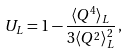<formula> <loc_0><loc_0><loc_500><loc_500>U _ { L } = 1 - \frac { \langle Q ^ { 4 } \rangle _ { L } } { 3 \langle Q ^ { 2 } \rangle ^ { 2 } _ { L } } \, ,</formula> 